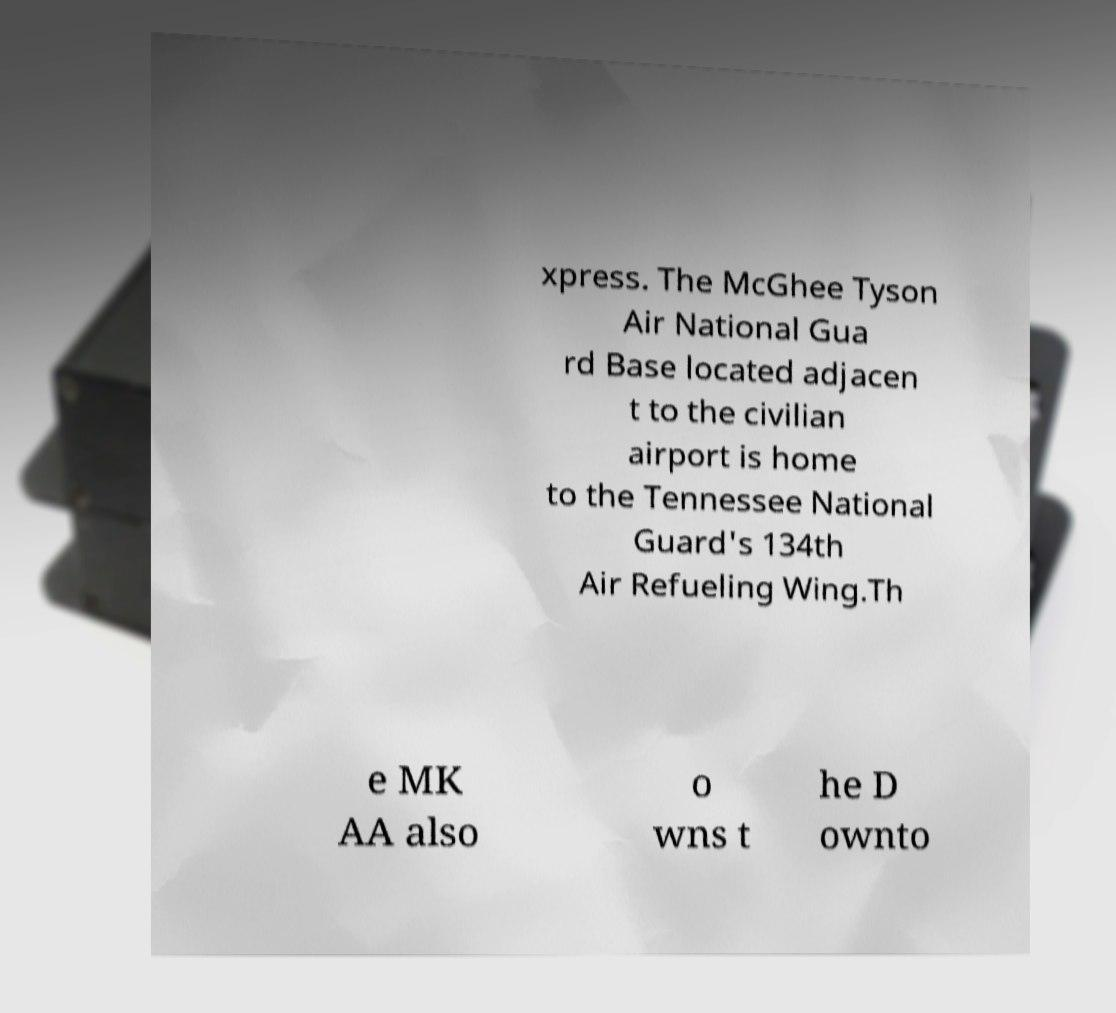There's text embedded in this image that I need extracted. Can you transcribe it verbatim? xpress. The McGhee Tyson Air National Gua rd Base located adjacen t to the civilian airport is home to the Tennessee National Guard's 134th Air Refueling Wing.Th e MK AA also o wns t he D ownto 